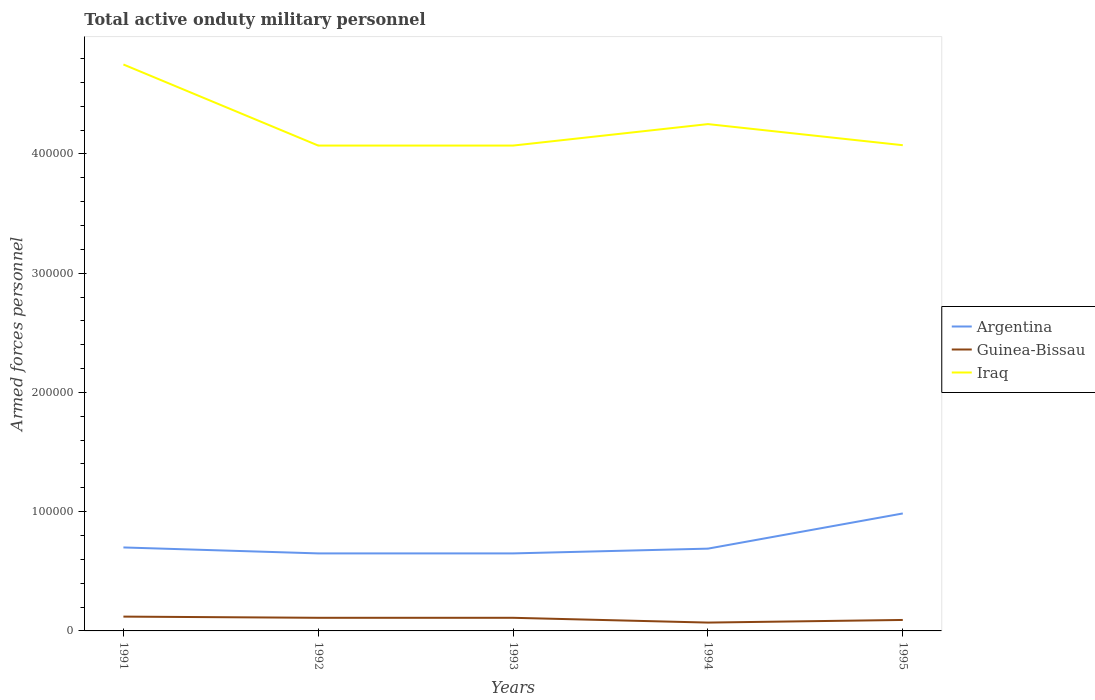Is the number of lines equal to the number of legend labels?
Your response must be concise. Yes. Across all years, what is the maximum number of armed forces personnel in Argentina?
Provide a short and direct response. 6.50e+04. What is the difference between the highest and the second highest number of armed forces personnel in Argentina?
Give a very brief answer. 3.35e+04. How many years are there in the graph?
Offer a terse response. 5. What is the difference between two consecutive major ticks on the Y-axis?
Offer a very short reply. 1.00e+05. How many legend labels are there?
Make the answer very short. 3. What is the title of the graph?
Your answer should be very brief. Total active onduty military personnel. What is the label or title of the Y-axis?
Your answer should be compact. Armed forces personnel. What is the Armed forces personnel of Argentina in 1991?
Ensure brevity in your answer.  7.00e+04. What is the Armed forces personnel of Guinea-Bissau in 1991?
Your response must be concise. 1.20e+04. What is the Armed forces personnel of Iraq in 1991?
Your answer should be compact. 4.75e+05. What is the Armed forces personnel in Argentina in 1992?
Provide a short and direct response. 6.50e+04. What is the Armed forces personnel in Guinea-Bissau in 1992?
Ensure brevity in your answer.  1.10e+04. What is the Armed forces personnel of Iraq in 1992?
Offer a terse response. 4.07e+05. What is the Armed forces personnel of Argentina in 1993?
Your answer should be compact. 6.50e+04. What is the Armed forces personnel in Guinea-Bissau in 1993?
Ensure brevity in your answer.  1.10e+04. What is the Armed forces personnel in Iraq in 1993?
Offer a terse response. 4.07e+05. What is the Armed forces personnel in Argentina in 1994?
Provide a succinct answer. 6.90e+04. What is the Armed forces personnel in Guinea-Bissau in 1994?
Offer a very short reply. 7000. What is the Armed forces personnel in Iraq in 1994?
Your answer should be compact. 4.25e+05. What is the Armed forces personnel of Argentina in 1995?
Make the answer very short. 9.85e+04. What is the Armed forces personnel of Guinea-Bissau in 1995?
Offer a terse response. 9200. What is the Armed forces personnel in Iraq in 1995?
Offer a terse response. 4.07e+05. Across all years, what is the maximum Armed forces personnel in Argentina?
Keep it short and to the point. 9.85e+04. Across all years, what is the maximum Armed forces personnel in Guinea-Bissau?
Offer a terse response. 1.20e+04. Across all years, what is the maximum Armed forces personnel of Iraq?
Provide a succinct answer. 4.75e+05. Across all years, what is the minimum Armed forces personnel of Argentina?
Provide a short and direct response. 6.50e+04. Across all years, what is the minimum Armed forces personnel in Guinea-Bissau?
Your answer should be very brief. 7000. Across all years, what is the minimum Armed forces personnel in Iraq?
Keep it short and to the point. 4.07e+05. What is the total Armed forces personnel in Argentina in the graph?
Offer a terse response. 3.68e+05. What is the total Armed forces personnel in Guinea-Bissau in the graph?
Offer a terse response. 5.02e+04. What is the total Armed forces personnel in Iraq in the graph?
Ensure brevity in your answer.  2.12e+06. What is the difference between the Armed forces personnel in Guinea-Bissau in 1991 and that in 1992?
Your answer should be very brief. 1000. What is the difference between the Armed forces personnel of Iraq in 1991 and that in 1992?
Your answer should be very brief. 6.80e+04. What is the difference between the Armed forces personnel of Argentina in 1991 and that in 1993?
Provide a short and direct response. 5000. What is the difference between the Armed forces personnel of Iraq in 1991 and that in 1993?
Your response must be concise. 6.80e+04. What is the difference between the Armed forces personnel of Argentina in 1991 and that in 1994?
Your answer should be very brief. 1000. What is the difference between the Armed forces personnel of Guinea-Bissau in 1991 and that in 1994?
Provide a short and direct response. 5000. What is the difference between the Armed forces personnel in Argentina in 1991 and that in 1995?
Give a very brief answer. -2.85e+04. What is the difference between the Armed forces personnel in Guinea-Bissau in 1991 and that in 1995?
Provide a succinct answer. 2800. What is the difference between the Armed forces personnel in Iraq in 1991 and that in 1995?
Provide a succinct answer. 6.77e+04. What is the difference between the Armed forces personnel of Argentina in 1992 and that in 1993?
Your answer should be compact. 0. What is the difference between the Armed forces personnel in Argentina in 1992 and that in 1994?
Offer a very short reply. -4000. What is the difference between the Armed forces personnel in Guinea-Bissau in 1992 and that in 1994?
Provide a short and direct response. 4000. What is the difference between the Armed forces personnel in Iraq in 1992 and that in 1994?
Make the answer very short. -1.80e+04. What is the difference between the Armed forces personnel in Argentina in 1992 and that in 1995?
Give a very brief answer. -3.35e+04. What is the difference between the Armed forces personnel in Guinea-Bissau in 1992 and that in 1995?
Keep it short and to the point. 1800. What is the difference between the Armed forces personnel of Iraq in 1992 and that in 1995?
Make the answer very short. -300. What is the difference between the Armed forces personnel of Argentina in 1993 and that in 1994?
Give a very brief answer. -4000. What is the difference between the Armed forces personnel in Guinea-Bissau in 1993 and that in 1994?
Your answer should be compact. 4000. What is the difference between the Armed forces personnel in Iraq in 1993 and that in 1994?
Your answer should be very brief. -1.80e+04. What is the difference between the Armed forces personnel of Argentina in 1993 and that in 1995?
Offer a terse response. -3.35e+04. What is the difference between the Armed forces personnel in Guinea-Bissau in 1993 and that in 1995?
Your answer should be compact. 1800. What is the difference between the Armed forces personnel in Iraq in 1993 and that in 1995?
Offer a terse response. -300. What is the difference between the Armed forces personnel in Argentina in 1994 and that in 1995?
Your answer should be compact. -2.95e+04. What is the difference between the Armed forces personnel of Guinea-Bissau in 1994 and that in 1995?
Make the answer very short. -2200. What is the difference between the Armed forces personnel of Iraq in 1994 and that in 1995?
Offer a terse response. 1.77e+04. What is the difference between the Armed forces personnel of Argentina in 1991 and the Armed forces personnel of Guinea-Bissau in 1992?
Provide a succinct answer. 5.90e+04. What is the difference between the Armed forces personnel in Argentina in 1991 and the Armed forces personnel in Iraq in 1992?
Keep it short and to the point. -3.37e+05. What is the difference between the Armed forces personnel of Guinea-Bissau in 1991 and the Armed forces personnel of Iraq in 1992?
Make the answer very short. -3.95e+05. What is the difference between the Armed forces personnel of Argentina in 1991 and the Armed forces personnel of Guinea-Bissau in 1993?
Make the answer very short. 5.90e+04. What is the difference between the Armed forces personnel of Argentina in 1991 and the Armed forces personnel of Iraq in 1993?
Your answer should be very brief. -3.37e+05. What is the difference between the Armed forces personnel in Guinea-Bissau in 1991 and the Armed forces personnel in Iraq in 1993?
Your answer should be very brief. -3.95e+05. What is the difference between the Armed forces personnel of Argentina in 1991 and the Armed forces personnel of Guinea-Bissau in 1994?
Offer a terse response. 6.30e+04. What is the difference between the Armed forces personnel of Argentina in 1991 and the Armed forces personnel of Iraq in 1994?
Ensure brevity in your answer.  -3.55e+05. What is the difference between the Armed forces personnel of Guinea-Bissau in 1991 and the Armed forces personnel of Iraq in 1994?
Offer a terse response. -4.13e+05. What is the difference between the Armed forces personnel of Argentina in 1991 and the Armed forces personnel of Guinea-Bissau in 1995?
Ensure brevity in your answer.  6.08e+04. What is the difference between the Armed forces personnel of Argentina in 1991 and the Armed forces personnel of Iraq in 1995?
Keep it short and to the point. -3.37e+05. What is the difference between the Armed forces personnel in Guinea-Bissau in 1991 and the Armed forces personnel in Iraq in 1995?
Make the answer very short. -3.95e+05. What is the difference between the Armed forces personnel in Argentina in 1992 and the Armed forces personnel in Guinea-Bissau in 1993?
Offer a terse response. 5.40e+04. What is the difference between the Armed forces personnel of Argentina in 1992 and the Armed forces personnel of Iraq in 1993?
Provide a succinct answer. -3.42e+05. What is the difference between the Armed forces personnel in Guinea-Bissau in 1992 and the Armed forces personnel in Iraq in 1993?
Offer a terse response. -3.96e+05. What is the difference between the Armed forces personnel in Argentina in 1992 and the Armed forces personnel in Guinea-Bissau in 1994?
Provide a succinct answer. 5.80e+04. What is the difference between the Armed forces personnel in Argentina in 1992 and the Armed forces personnel in Iraq in 1994?
Your answer should be compact. -3.60e+05. What is the difference between the Armed forces personnel in Guinea-Bissau in 1992 and the Armed forces personnel in Iraq in 1994?
Your response must be concise. -4.14e+05. What is the difference between the Armed forces personnel in Argentina in 1992 and the Armed forces personnel in Guinea-Bissau in 1995?
Offer a terse response. 5.58e+04. What is the difference between the Armed forces personnel in Argentina in 1992 and the Armed forces personnel in Iraq in 1995?
Offer a very short reply. -3.42e+05. What is the difference between the Armed forces personnel in Guinea-Bissau in 1992 and the Armed forces personnel in Iraq in 1995?
Your response must be concise. -3.96e+05. What is the difference between the Armed forces personnel of Argentina in 1993 and the Armed forces personnel of Guinea-Bissau in 1994?
Your answer should be compact. 5.80e+04. What is the difference between the Armed forces personnel in Argentina in 1993 and the Armed forces personnel in Iraq in 1994?
Ensure brevity in your answer.  -3.60e+05. What is the difference between the Armed forces personnel in Guinea-Bissau in 1993 and the Armed forces personnel in Iraq in 1994?
Make the answer very short. -4.14e+05. What is the difference between the Armed forces personnel of Argentina in 1993 and the Armed forces personnel of Guinea-Bissau in 1995?
Your answer should be very brief. 5.58e+04. What is the difference between the Armed forces personnel of Argentina in 1993 and the Armed forces personnel of Iraq in 1995?
Make the answer very short. -3.42e+05. What is the difference between the Armed forces personnel of Guinea-Bissau in 1993 and the Armed forces personnel of Iraq in 1995?
Offer a very short reply. -3.96e+05. What is the difference between the Armed forces personnel of Argentina in 1994 and the Armed forces personnel of Guinea-Bissau in 1995?
Offer a terse response. 5.98e+04. What is the difference between the Armed forces personnel of Argentina in 1994 and the Armed forces personnel of Iraq in 1995?
Make the answer very short. -3.38e+05. What is the difference between the Armed forces personnel of Guinea-Bissau in 1994 and the Armed forces personnel of Iraq in 1995?
Your response must be concise. -4.00e+05. What is the average Armed forces personnel in Argentina per year?
Offer a terse response. 7.35e+04. What is the average Armed forces personnel in Guinea-Bissau per year?
Your response must be concise. 1.00e+04. What is the average Armed forces personnel in Iraq per year?
Your answer should be compact. 4.24e+05. In the year 1991, what is the difference between the Armed forces personnel in Argentina and Armed forces personnel in Guinea-Bissau?
Provide a succinct answer. 5.80e+04. In the year 1991, what is the difference between the Armed forces personnel in Argentina and Armed forces personnel in Iraq?
Keep it short and to the point. -4.05e+05. In the year 1991, what is the difference between the Armed forces personnel in Guinea-Bissau and Armed forces personnel in Iraq?
Your response must be concise. -4.63e+05. In the year 1992, what is the difference between the Armed forces personnel in Argentina and Armed forces personnel in Guinea-Bissau?
Provide a short and direct response. 5.40e+04. In the year 1992, what is the difference between the Armed forces personnel of Argentina and Armed forces personnel of Iraq?
Your answer should be compact. -3.42e+05. In the year 1992, what is the difference between the Armed forces personnel of Guinea-Bissau and Armed forces personnel of Iraq?
Offer a very short reply. -3.96e+05. In the year 1993, what is the difference between the Armed forces personnel in Argentina and Armed forces personnel in Guinea-Bissau?
Your answer should be compact. 5.40e+04. In the year 1993, what is the difference between the Armed forces personnel of Argentina and Armed forces personnel of Iraq?
Your answer should be very brief. -3.42e+05. In the year 1993, what is the difference between the Armed forces personnel in Guinea-Bissau and Armed forces personnel in Iraq?
Make the answer very short. -3.96e+05. In the year 1994, what is the difference between the Armed forces personnel of Argentina and Armed forces personnel of Guinea-Bissau?
Ensure brevity in your answer.  6.20e+04. In the year 1994, what is the difference between the Armed forces personnel of Argentina and Armed forces personnel of Iraq?
Your answer should be very brief. -3.56e+05. In the year 1994, what is the difference between the Armed forces personnel in Guinea-Bissau and Armed forces personnel in Iraq?
Offer a very short reply. -4.18e+05. In the year 1995, what is the difference between the Armed forces personnel in Argentina and Armed forces personnel in Guinea-Bissau?
Offer a terse response. 8.93e+04. In the year 1995, what is the difference between the Armed forces personnel of Argentina and Armed forces personnel of Iraq?
Make the answer very short. -3.09e+05. In the year 1995, what is the difference between the Armed forces personnel in Guinea-Bissau and Armed forces personnel in Iraq?
Keep it short and to the point. -3.98e+05. What is the ratio of the Armed forces personnel in Guinea-Bissau in 1991 to that in 1992?
Provide a short and direct response. 1.09. What is the ratio of the Armed forces personnel in Iraq in 1991 to that in 1992?
Provide a succinct answer. 1.17. What is the ratio of the Armed forces personnel in Guinea-Bissau in 1991 to that in 1993?
Your answer should be very brief. 1.09. What is the ratio of the Armed forces personnel in Iraq in 1991 to that in 1993?
Offer a terse response. 1.17. What is the ratio of the Armed forces personnel in Argentina in 1991 to that in 1994?
Offer a terse response. 1.01. What is the ratio of the Armed forces personnel in Guinea-Bissau in 1991 to that in 1994?
Provide a short and direct response. 1.71. What is the ratio of the Armed forces personnel in Iraq in 1991 to that in 1994?
Ensure brevity in your answer.  1.12. What is the ratio of the Armed forces personnel of Argentina in 1991 to that in 1995?
Offer a very short reply. 0.71. What is the ratio of the Armed forces personnel of Guinea-Bissau in 1991 to that in 1995?
Provide a succinct answer. 1.3. What is the ratio of the Armed forces personnel in Iraq in 1991 to that in 1995?
Keep it short and to the point. 1.17. What is the ratio of the Armed forces personnel of Argentina in 1992 to that in 1993?
Your answer should be very brief. 1. What is the ratio of the Armed forces personnel of Guinea-Bissau in 1992 to that in 1993?
Offer a very short reply. 1. What is the ratio of the Armed forces personnel of Argentina in 1992 to that in 1994?
Give a very brief answer. 0.94. What is the ratio of the Armed forces personnel of Guinea-Bissau in 1992 to that in 1994?
Provide a succinct answer. 1.57. What is the ratio of the Armed forces personnel in Iraq in 1992 to that in 1994?
Keep it short and to the point. 0.96. What is the ratio of the Armed forces personnel of Argentina in 1992 to that in 1995?
Provide a succinct answer. 0.66. What is the ratio of the Armed forces personnel in Guinea-Bissau in 1992 to that in 1995?
Your answer should be compact. 1.2. What is the ratio of the Armed forces personnel of Iraq in 1992 to that in 1995?
Provide a succinct answer. 1. What is the ratio of the Armed forces personnel of Argentina in 1993 to that in 1994?
Offer a very short reply. 0.94. What is the ratio of the Armed forces personnel of Guinea-Bissau in 1993 to that in 1994?
Your response must be concise. 1.57. What is the ratio of the Armed forces personnel in Iraq in 1993 to that in 1994?
Keep it short and to the point. 0.96. What is the ratio of the Armed forces personnel in Argentina in 1993 to that in 1995?
Your answer should be very brief. 0.66. What is the ratio of the Armed forces personnel of Guinea-Bissau in 1993 to that in 1995?
Give a very brief answer. 1.2. What is the ratio of the Armed forces personnel of Iraq in 1993 to that in 1995?
Provide a short and direct response. 1. What is the ratio of the Armed forces personnel in Argentina in 1994 to that in 1995?
Give a very brief answer. 0.7. What is the ratio of the Armed forces personnel of Guinea-Bissau in 1994 to that in 1995?
Your answer should be very brief. 0.76. What is the ratio of the Armed forces personnel of Iraq in 1994 to that in 1995?
Your answer should be very brief. 1.04. What is the difference between the highest and the second highest Armed forces personnel of Argentina?
Your answer should be very brief. 2.85e+04. What is the difference between the highest and the second highest Armed forces personnel in Guinea-Bissau?
Offer a terse response. 1000. What is the difference between the highest and the lowest Armed forces personnel of Argentina?
Keep it short and to the point. 3.35e+04. What is the difference between the highest and the lowest Armed forces personnel in Iraq?
Provide a short and direct response. 6.80e+04. 